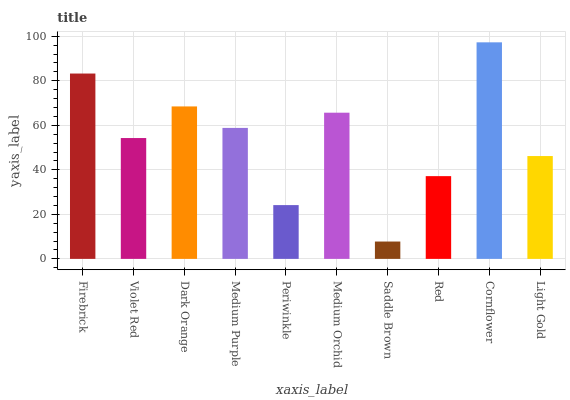Is Saddle Brown the minimum?
Answer yes or no. Yes. Is Cornflower the maximum?
Answer yes or no. Yes. Is Violet Red the minimum?
Answer yes or no. No. Is Violet Red the maximum?
Answer yes or no. No. Is Firebrick greater than Violet Red?
Answer yes or no. Yes. Is Violet Red less than Firebrick?
Answer yes or no. Yes. Is Violet Red greater than Firebrick?
Answer yes or no. No. Is Firebrick less than Violet Red?
Answer yes or no. No. Is Medium Purple the high median?
Answer yes or no. Yes. Is Violet Red the low median?
Answer yes or no. Yes. Is Saddle Brown the high median?
Answer yes or no. No. Is Medium Purple the low median?
Answer yes or no. No. 